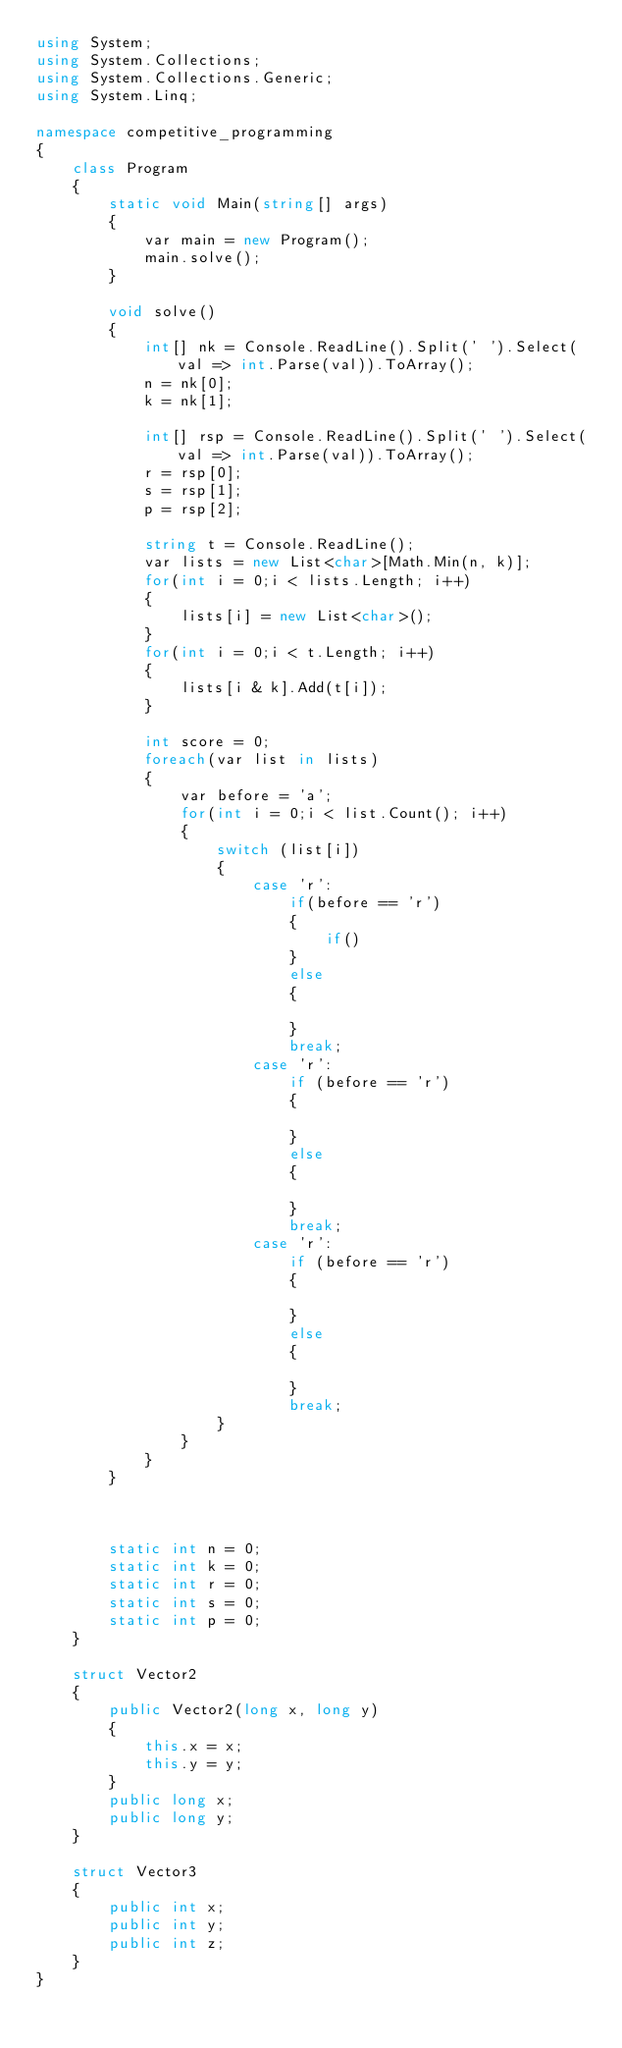Convert code to text. <code><loc_0><loc_0><loc_500><loc_500><_C#_>using System;
using System.Collections;
using System.Collections.Generic;
using System.Linq;

namespace competitive_programming
{
    class Program
    {
        static void Main(string[] args)
        {
            var main = new Program();
            main.solve();
        }

        void solve()
        {
            int[] nk = Console.ReadLine().Split(' ').Select(val => int.Parse(val)).ToArray();
            n = nk[0];
            k = nk[1];

            int[] rsp = Console.ReadLine().Split(' ').Select(val => int.Parse(val)).ToArray();
            r = rsp[0];
            s = rsp[1];
            p = rsp[2];

            string t = Console.ReadLine();
            var lists = new List<char>[Math.Min(n, k)];
            for(int i = 0;i < lists.Length; i++)
            {
                lists[i] = new List<char>();
            }
            for(int i = 0;i < t.Length; i++)
            {
                lists[i & k].Add(t[i]);
            }

            int score = 0;
            foreach(var list in lists)
            {
                var before = 'a';
                for(int i = 0;i < list.Count(); i++)
                {
                    switch (list[i])
                    {
                        case 'r':
                            if(before == 'r')
                            {
                                if()
                            }
                            else
                            {

                            }
                            break;
                        case 'r':
                            if (before == 'r')
                            {

                            }
                            else
                            {

                            }
                            break;
                        case 'r':
                            if (before == 'r')
                            {

                            }
                            else
                            {

                            }
                            break;
                    }
                }
            }
        }



        static int n = 0;
        static int k = 0;
        static int r = 0;
        static int s = 0;
        static int p = 0;
    }

    struct Vector2
    {
        public Vector2(long x, long y)
        {
            this.x = x;
            this.y = y;
        }
        public long x;
        public long y;
    }

    struct Vector3
    {
        public int x;
        public int y;
        public int z;
    }
}
</code> 